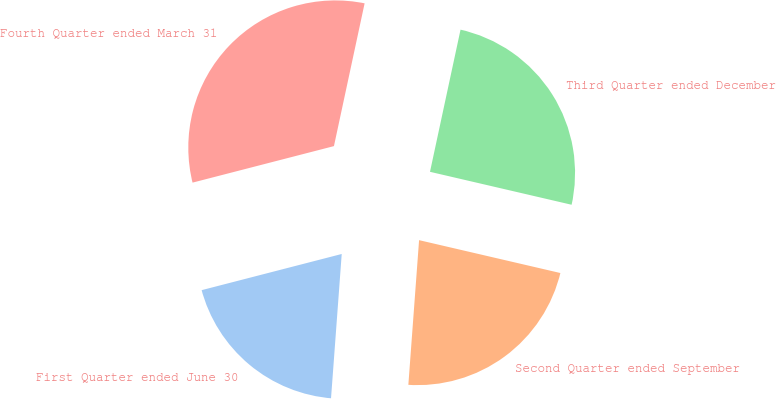<chart> <loc_0><loc_0><loc_500><loc_500><pie_chart><fcel>First Quarter ended June 30<fcel>Second Quarter ended September<fcel>Third Quarter ended December<fcel>Fourth Quarter ended March 31<nl><fcel>19.8%<fcel>22.54%<fcel>25.27%<fcel>32.39%<nl></chart> 